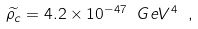<formula> <loc_0><loc_0><loc_500><loc_500>\widetilde { \rho _ { c } } = 4 . 2 \times 1 0 ^ { - 4 7 } \ G e V ^ { 4 } \ ,</formula> 